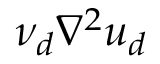Convert formula to latex. <formula><loc_0><loc_0><loc_500><loc_500>\nu _ { d } \nabla ^ { 2 } u _ { d }</formula> 